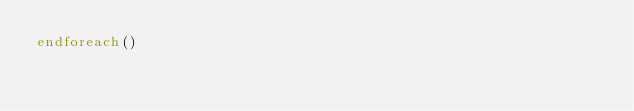<code> <loc_0><loc_0><loc_500><loc_500><_CMake_>endforeach()
</code> 